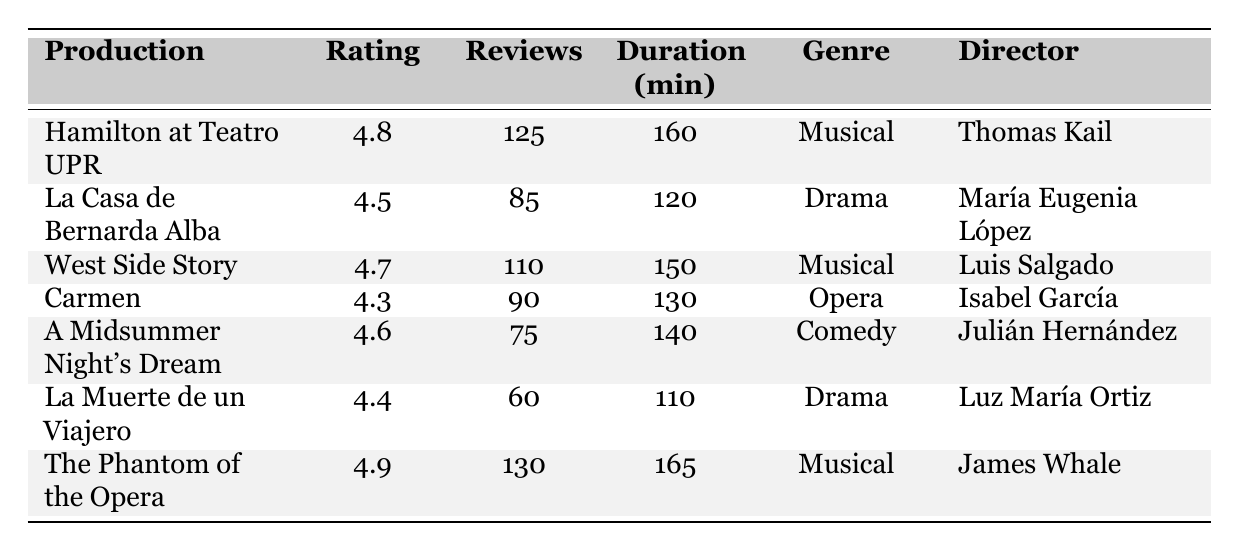What's the highest-rated production? By looking at the "Rating" column, "The Phantom of the Opera" has the highest rating of 4.9.
Answer: 4.9 Which production has the longest duration? Checking the "Duration (min)" column, "The Phantom of the Opera" has the longest duration at 165 minutes.
Answer: 165 minutes How many reviews does "La Casa de Bernarda Alba" have? Referring to the "Reviews" column for "La Casa de Bernarda Alba," it shows 85 reviews.
Answer: 85 What is the average rating of the musicals listed? The ratings for the musicals are 4.8 (Hamilton), 4.7 (West Side Story), and 4.9 (The Phantom of the Opera). The average is (4.8 + 4.7 + 4.9) / 3 = 4.733.
Answer: 4.733 Is "Carmen" directed by Isabel García? In the table, the director of "Carmen" is listed as Isabel García, so the statement is true.
Answer: Yes Which genre has the highest average rating? The ratings by genre are: Musical (4.73), Drama (4.45), Opera (4.3), Comedy (4.6). The average of the musicals is highest at 4.73.
Answer: Musical What is the combined total of reviews for all productions? The number of reviews is: 125 + 85 + 110 + 90 + 75 + 60 + 130 = 775, which is the total for all productions.
Answer: 775 How many productions have a rating above 4.5? The productions with ratings above 4.5 are: Hamilton (4.8), West Side Story (4.7), The Phantom of the Opera (4.9), La Casa de Bernarda Alba (4.5), and A Midsummer Night's Dream (4.6). That's 5 productions.
Answer: 5 What was the performance date of "A Midsummer Night's Dream"? The performance date is clearly listed in the table as August 5, 2022.
Answer: August 5, 2022 Is there a production from 2021? Yes, "West Side Story" is listed with the year 2021, confirming a production from that year exists.
Answer: Yes Which production has the fewest reviews? The production with the fewest reviews is "La Muerte de un Viajero" with 60 reviews.
Answer: 60 reviews 